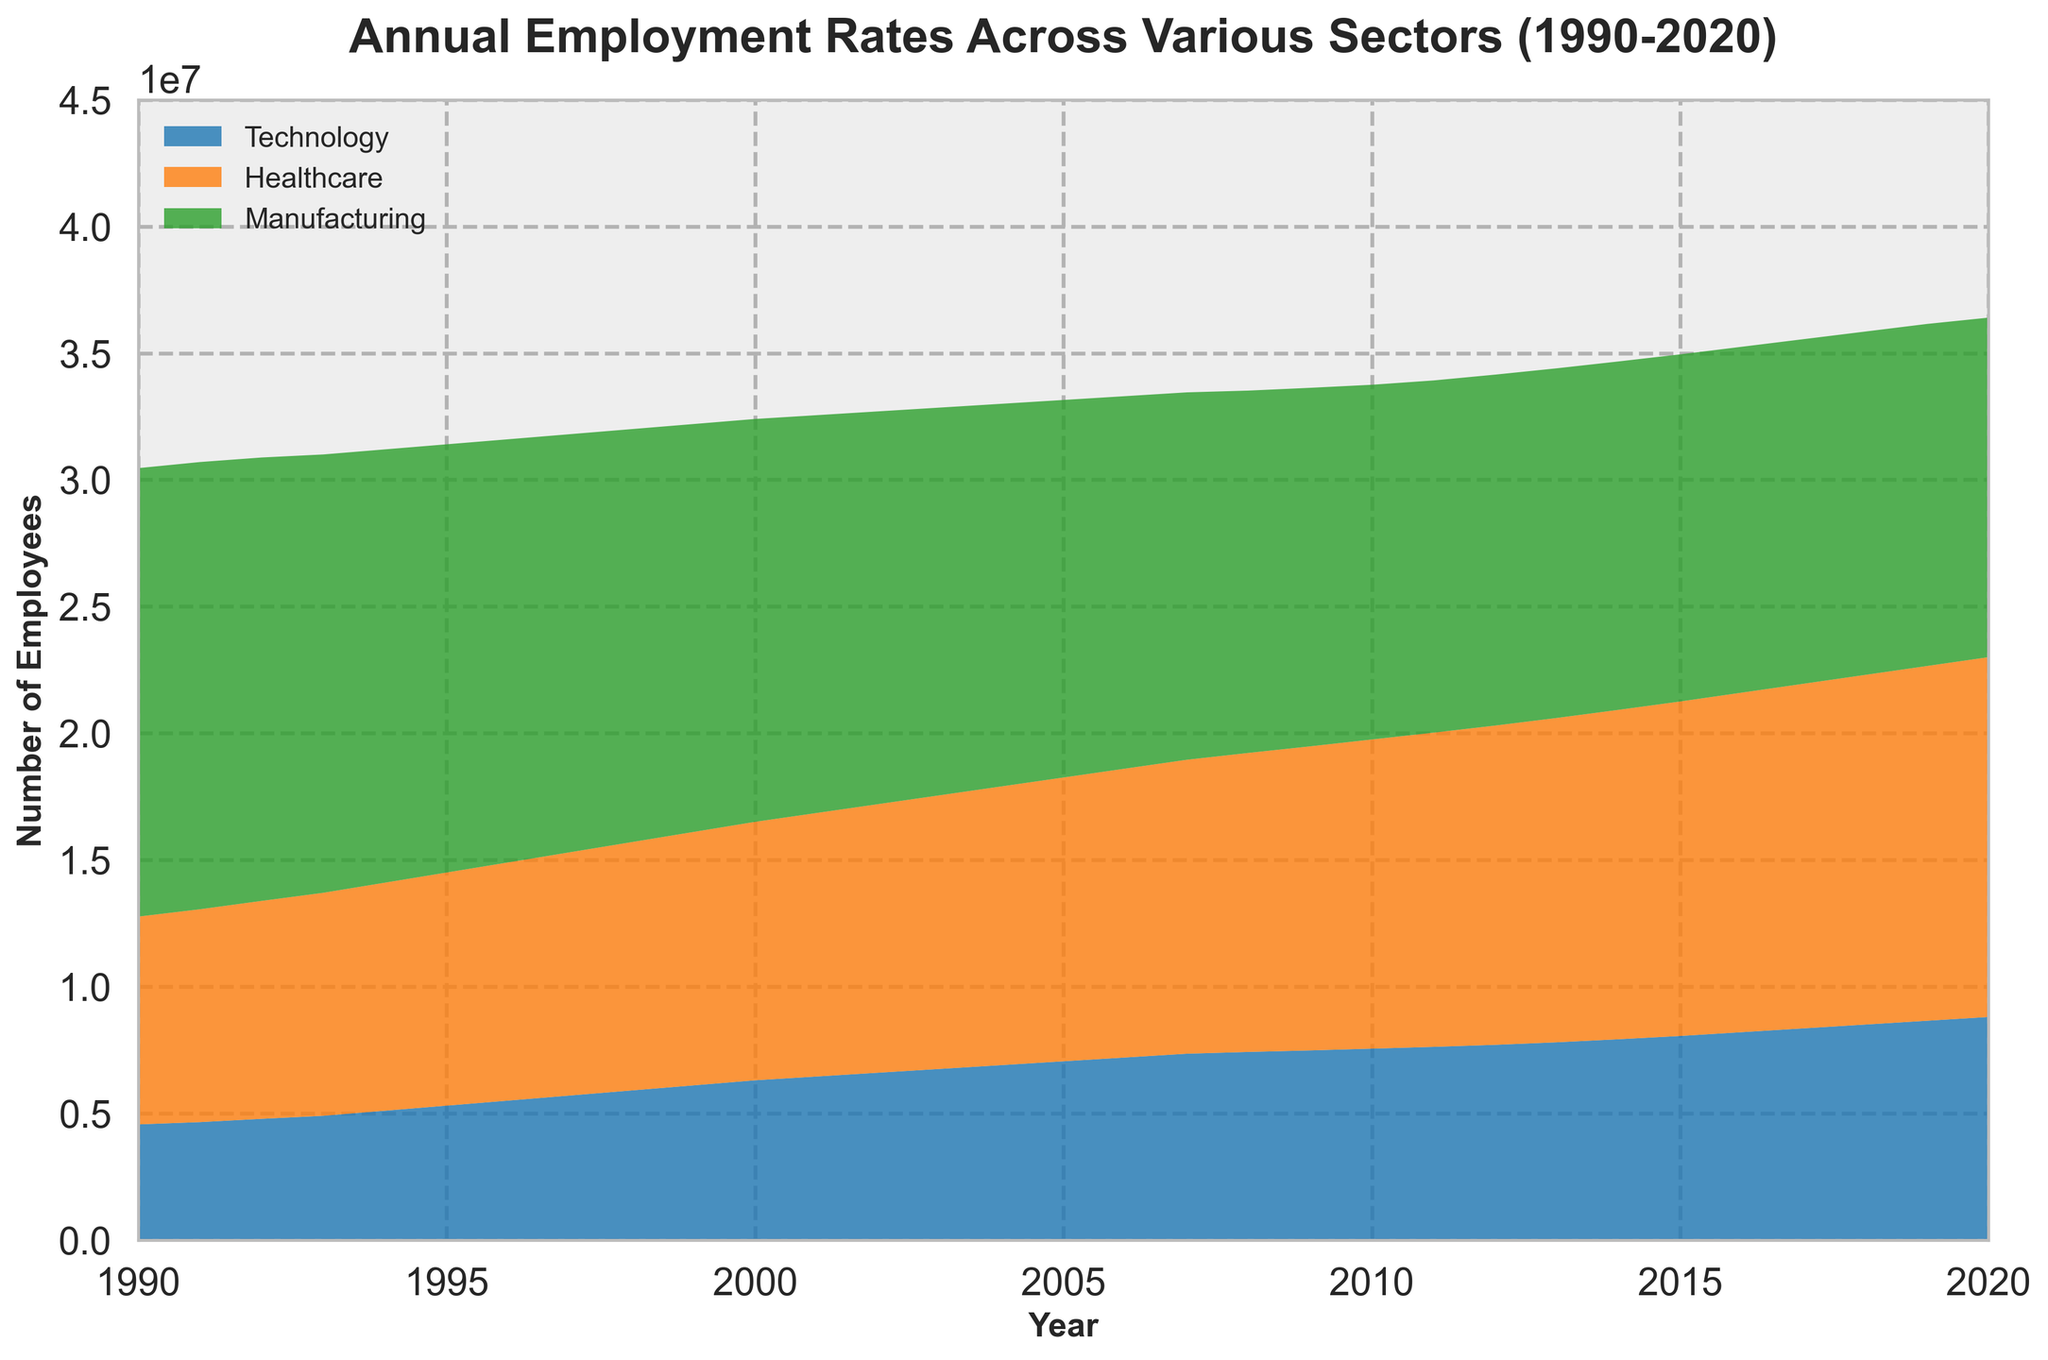Which sector had the highest employment rate in 2020? From the area chart, it's clear that the sector with the highest area at the top represents the highest employment rate. In 2020, Healthcare is at the top, indicating the highest employment.
Answer: Healthcare How did employment in the Manufacturing sector change from 1990 to 2020? By observing the area designated for Manufacturing over time, it can be seen that the area decreases. Employment in Manufacturing dropped from 17.7 million in 1990 to 13.4 million in 2020.
Answer: Decreased Which sector showed a consistent increase in employment from 1990 to 2020? Observing the stacked areas of the chart, Technology and Healthcare both show consistent increases as their areas continue to grow without any decreases.
Answer: Two sectors: Technology, Healthcare By how much did the employment in the Technology sector rise from 1990 to 2000? In 1990, Technology had 4.56 million employees, and in 2000, it had 6.3 million. Subtracting these values (6.3 - 4.56) gives us the increase.
Answer: 1.74 million Compare the employment growth between Technology and Healthcare from 1990 to 2020. Which sector grew more? Technology grew from 4.56 million to 8.8 million, an increment of 4.24 million. Healthcare grew from 8.2 million to 14.2 million, an increment of 6 million. Since 6 million is larger than 4.24 million, Healthcare grew more.
Answer: Healthcare In which year did the total employment across all three sectors seem to peak? By observing the combined area size, we can see that the point at which the three areas combined appear the largest is around 2020.
Answer: 2020 What can you say about the employment trend in the Manufacturing sector during the 2008 financial crisis? Around the 2008 financial crisis, the area representing Manufacturing decreases more significantly, indicating a drop in employment.
Answer: Decreased Which sector had the smallest change in employment from 1990 to 2020? By looking at the difference in the areas, Manufacturing had a decrease, Technology and Healthcare had increases. Technology's change (4.24 million) is smaller than Healthcare's (6 million), making it the smallest change among the shown increases.
Answer: Technology What is the difference in employment between Healthcare and Technology sectors in 2020? In 2020, Healthcare had 14.2 million employees, and Technology had 8.8 million. Subtracting these values (14.2 - 8.8) gives the difference.
Answer: 5.4 million 